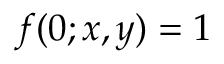Convert formula to latex. <formula><loc_0><loc_0><loc_500><loc_500>f ( 0 ; x , y ) = 1</formula> 